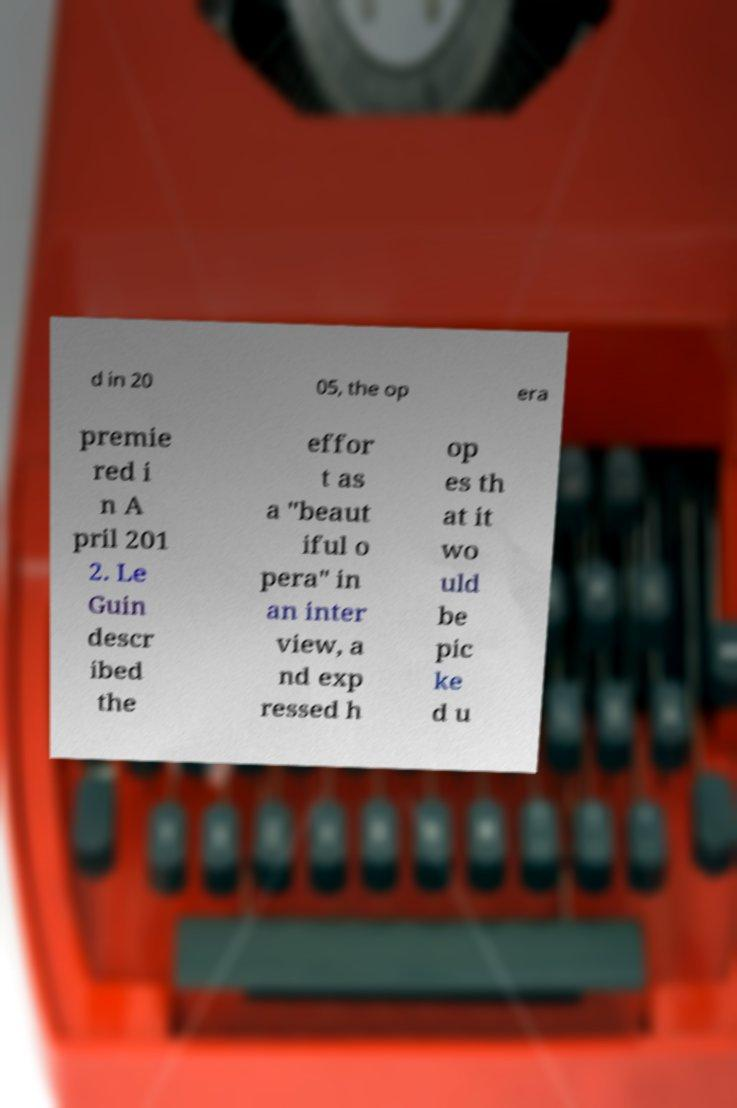There's text embedded in this image that I need extracted. Can you transcribe it verbatim? d in 20 05, the op era premie red i n A pril 201 2. Le Guin descr ibed the effor t as a "beaut iful o pera" in an inter view, a nd exp ressed h op es th at it wo uld be pic ke d u 